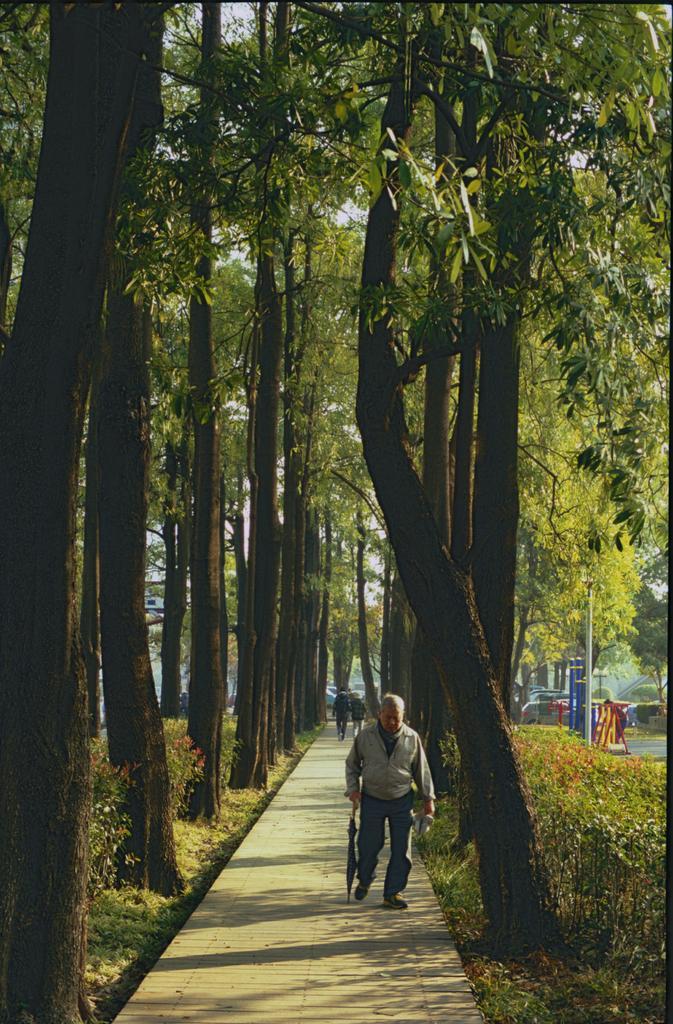Can you describe this image briefly? At the bottom of the image I can see few people are walking on the boardwalk. On the both sides I can see the plants and trees. In the background, I can see few vehicles and a pole. 